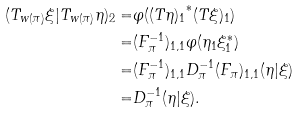<formula> <loc_0><loc_0><loc_500><loc_500>( T _ { w ( \pi ) } \xi | T _ { w ( \pi ) } \eta ) _ { 2 } = & \varphi ( { ( T \eta ) _ { 1 } } ^ { * } ( T \xi ) _ { 1 } ) \\ = & ( F _ { \pi } ^ { - 1 } ) _ { 1 , 1 } \varphi ( \eta _ { 1 } \xi _ { 1 } ^ { * } ) \\ = & ( F _ { \pi } ^ { - 1 } ) _ { 1 , 1 } D _ { \pi } ^ { - 1 } ( F _ { \pi } ) _ { 1 , 1 } ( \eta | \xi ) \\ = & D _ { \pi } ^ { - 1 } ( \eta | \xi ) .</formula> 